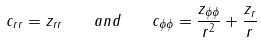<formula> <loc_0><loc_0><loc_500><loc_500>c _ { r r } = z _ { r r } \quad a n d \quad c _ { \phi \phi } = \frac { z _ { \phi \phi } } { r ^ { 2 } } + \frac { z _ { r } } { r }</formula> 